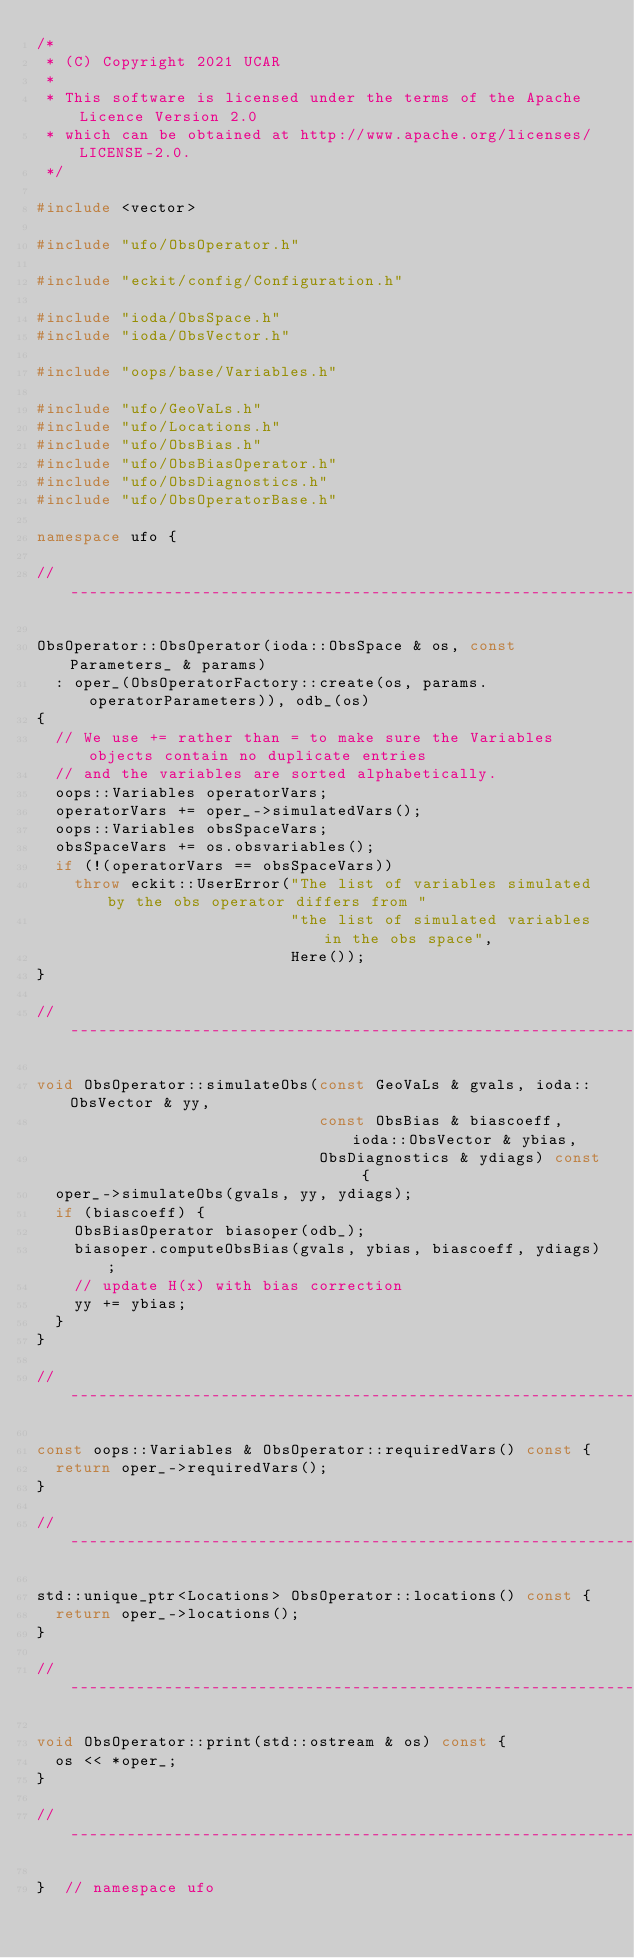<code> <loc_0><loc_0><loc_500><loc_500><_C++_>/*
 * (C) Copyright 2021 UCAR
 *
 * This software is licensed under the terms of the Apache Licence Version 2.0
 * which can be obtained at http://www.apache.org/licenses/LICENSE-2.0.
 */

#include <vector>

#include "ufo/ObsOperator.h"

#include "eckit/config/Configuration.h"

#include "ioda/ObsSpace.h"
#include "ioda/ObsVector.h"

#include "oops/base/Variables.h"

#include "ufo/GeoVaLs.h"
#include "ufo/Locations.h"
#include "ufo/ObsBias.h"
#include "ufo/ObsBiasOperator.h"
#include "ufo/ObsDiagnostics.h"
#include "ufo/ObsOperatorBase.h"

namespace ufo {

// -----------------------------------------------------------------------------

ObsOperator::ObsOperator(ioda::ObsSpace & os, const Parameters_ & params)
  : oper_(ObsOperatorFactory::create(os, params.operatorParameters)), odb_(os)
{
  // We use += rather than = to make sure the Variables objects contain no duplicate entries
  // and the variables are sorted alphabetically.
  oops::Variables operatorVars;
  operatorVars += oper_->simulatedVars();
  oops::Variables obsSpaceVars;
  obsSpaceVars += os.obsvariables();
  if (!(operatorVars == obsSpaceVars))
    throw eckit::UserError("The list of variables simulated by the obs operator differs from "
                           "the list of simulated variables in the obs space",
                           Here());
}

// -----------------------------------------------------------------------------

void ObsOperator::simulateObs(const GeoVaLs & gvals, ioda::ObsVector & yy,
                              const ObsBias & biascoeff, ioda::ObsVector & ybias,
                              ObsDiagnostics & ydiags) const {
  oper_->simulateObs(gvals, yy, ydiags);
  if (biascoeff) {
    ObsBiasOperator biasoper(odb_);
    biasoper.computeObsBias(gvals, ybias, biascoeff, ydiags);
    // update H(x) with bias correction
    yy += ybias;
  }
}

// -----------------------------------------------------------------------------

const oops::Variables & ObsOperator::requiredVars() const {
  return oper_->requiredVars();
}

// -----------------------------------------------------------------------------

std::unique_ptr<Locations> ObsOperator::locations() const {
  return oper_->locations();
}

// -----------------------------------------------------------------------------

void ObsOperator::print(std::ostream & os) const {
  os << *oper_;
}

// -----------------------------------------------------------------------------

}  // namespace ufo
</code> 